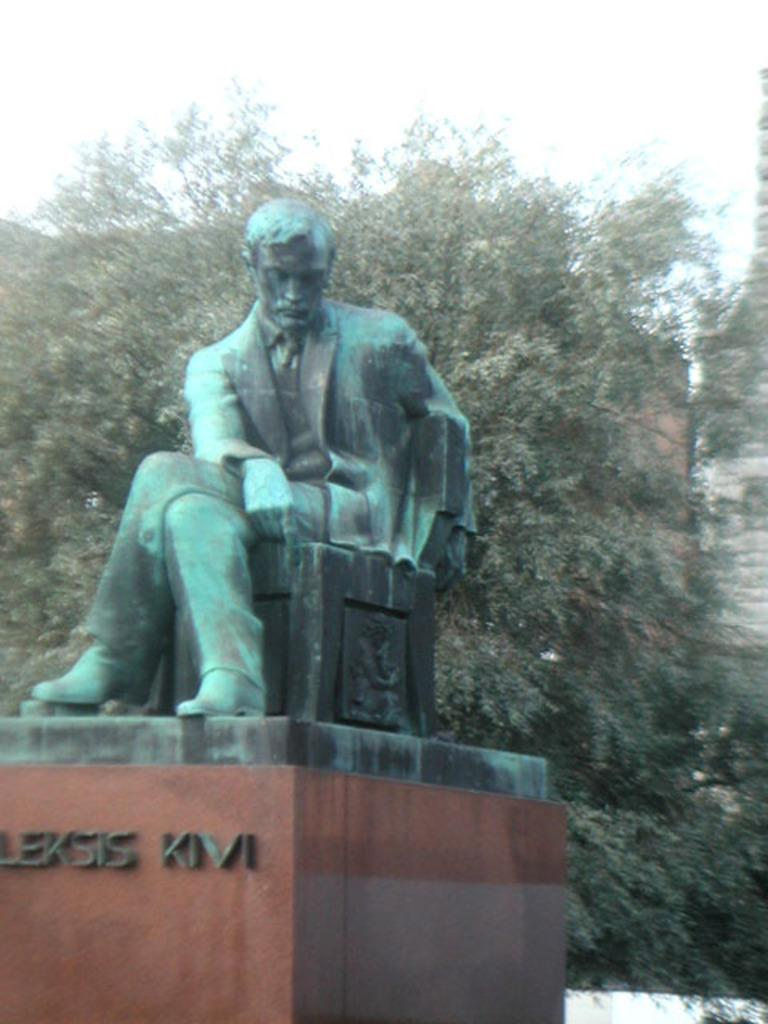What is the main subject in the center of the image? There is a statue in the center of the image. What can be seen on the statue? There is text on the statue. What type of natural elements are visible in the background of the image? There are trees in the background of the image. What type of man-made structures are visible in the background of the image? There are buildings in the background of the image. What is visible at the top of the image? The sky is visible at the top of the image. Can you describe the trail that leads to the statue in the image? There is no trail visible in the image; it only shows the statue, text on the statue, trees, buildings, and the sky. 